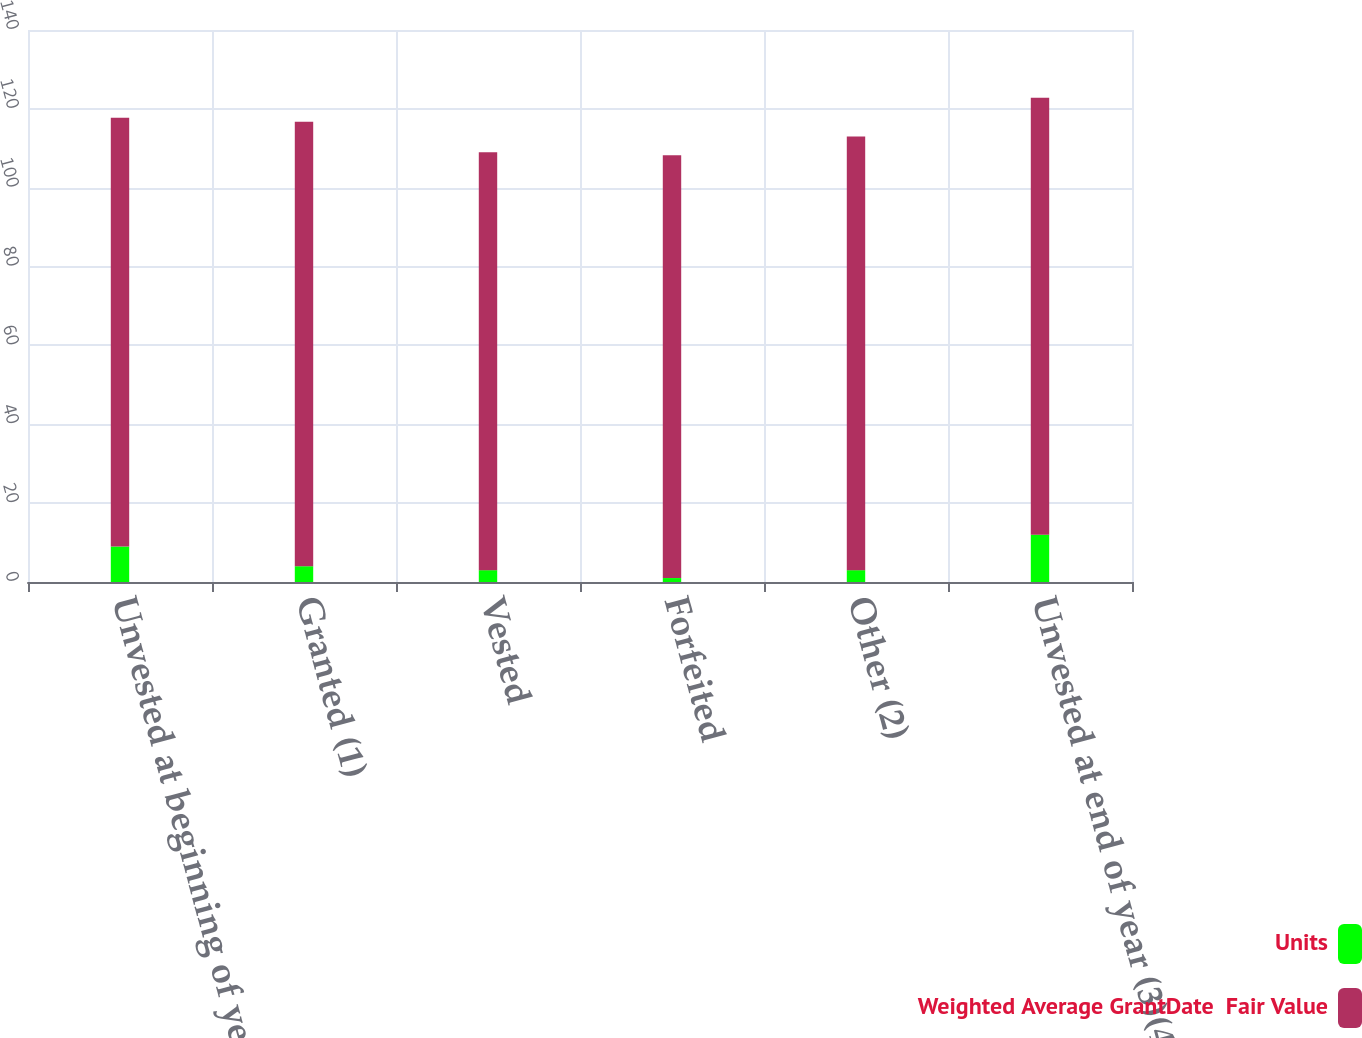Convert chart to OTSL. <chart><loc_0><loc_0><loc_500><loc_500><stacked_bar_chart><ecel><fcel>Unvested at beginning of year<fcel>Granted (1)<fcel>Vested<fcel>Forfeited<fcel>Other (2)<fcel>Unvested at end of year (3)(4)<nl><fcel>Units<fcel>9<fcel>4<fcel>3<fcel>1<fcel>3<fcel>12<nl><fcel>Weighted Average GrantDate  Fair Value<fcel>108.74<fcel>112.73<fcel>105.98<fcel>107.24<fcel>110<fcel>110.84<nl></chart> 